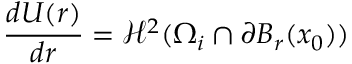<formula> <loc_0><loc_0><loc_500><loc_500>\frac { d U ( r ) } { d r } = \mathcal { H } ^ { 2 } ( \Omega _ { i } \cap \partial B _ { r } ( x _ { 0 } ) )</formula> 